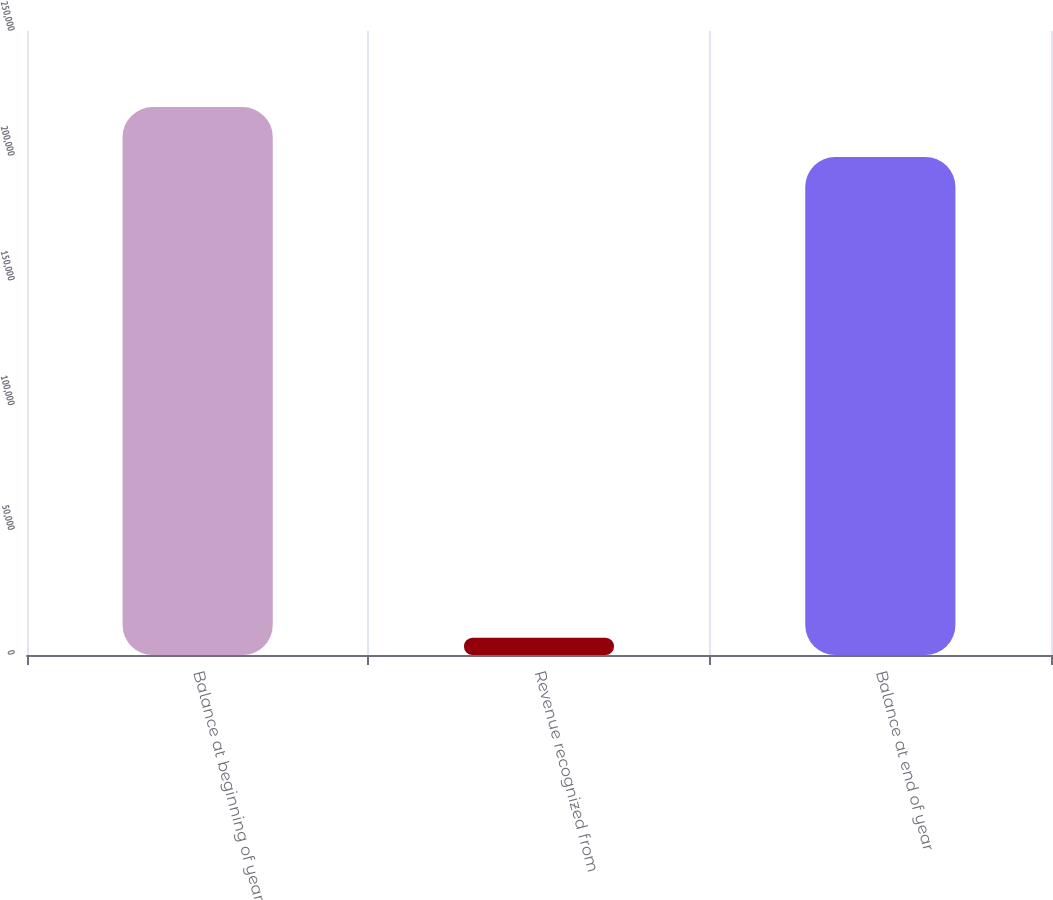Convert chart to OTSL. <chart><loc_0><loc_0><loc_500><loc_500><bar_chart><fcel>Balance at beginning of year<fcel>Revenue recognized from<fcel>Balance at end of year<nl><fcel>219512<fcel>6912<fcel>199556<nl></chart> 